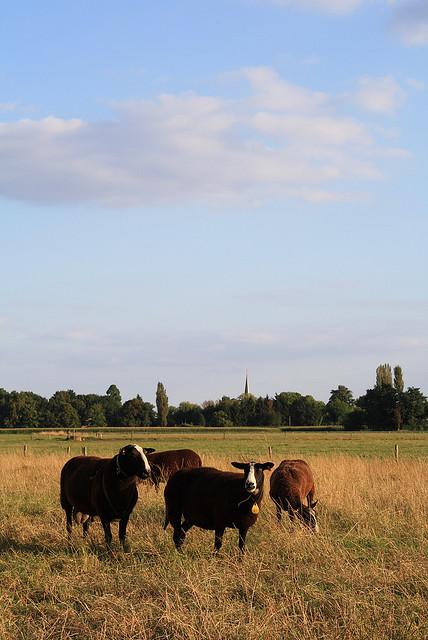How many legs are on the sheep above?
Give a very brief answer. 4. What animal is pictured?
Write a very short answer. Cow. How many cows?
Concise answer only. 4. Does the animal have horns?
Answer briefly. No. Why do the cows have tags?
Give a very brief answer. Yes. Is this the city?
Give a very brief answer. No. How many animals can be seen?
Be succinct. 4. What breed of livestock is shown?
Give a very brief answer. Cows. What colors are the cows?
Quick response, please. Brown. 